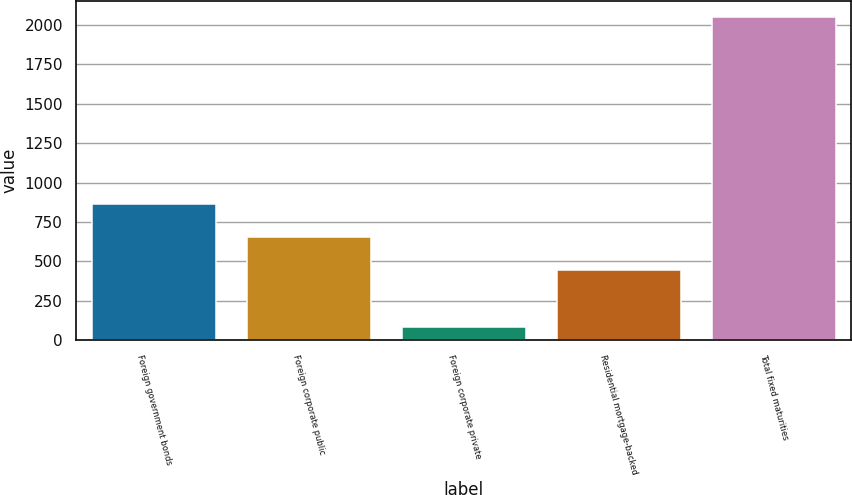<chart> <loc_0><loc_0><loc_500><loc_500><bar_chart><fcel>Foreign government bonds<fcel>Foreign corporate public<fcel>Foreign corporate private<fcel>Residential mortgage-backed<fcel>Total fixed maturities<nl><fcel>865<fcel>654<fcel>84<fcel>446<fcel>2049<nl></chart> 